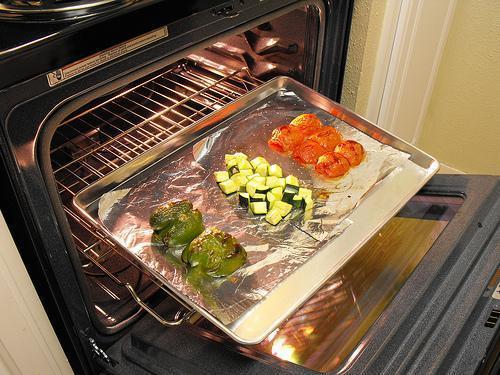How many peppers are there?
Give a very brief answer. 2. 